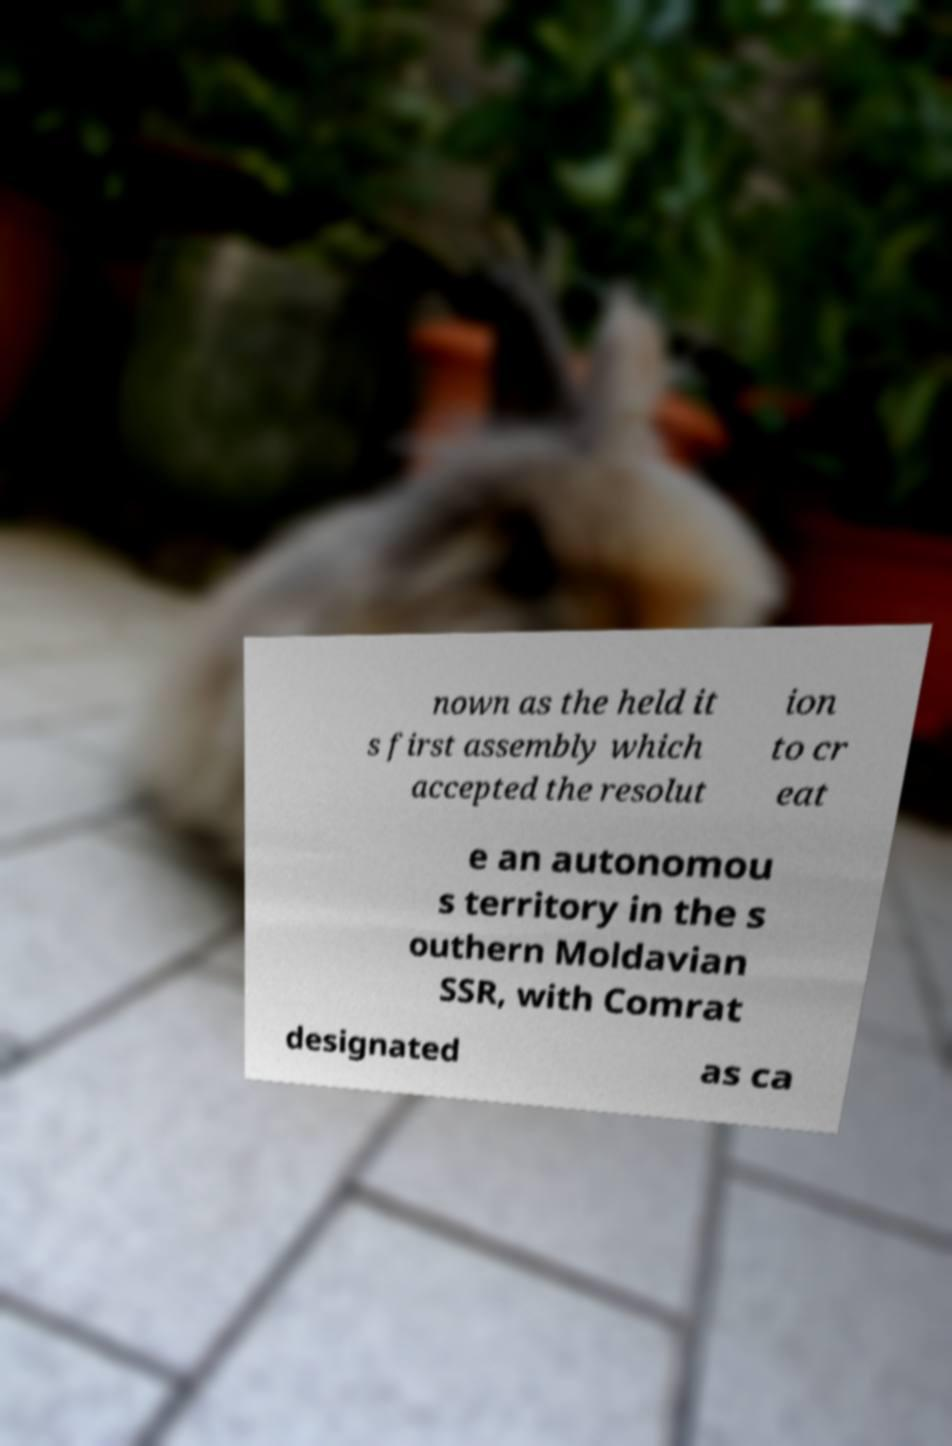What messages or text are displayed in this image? I need them in a readable, typed format. nown as the held it s first assembly which accepted the resolut ion to cr eat e an autonomou s territory in the s outhern Moldavian SSR, with Comrat designated as ca 